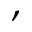Convert formula to latex. <formula><loc_0><loc_0><loc_500><loc_500>,</formula> 